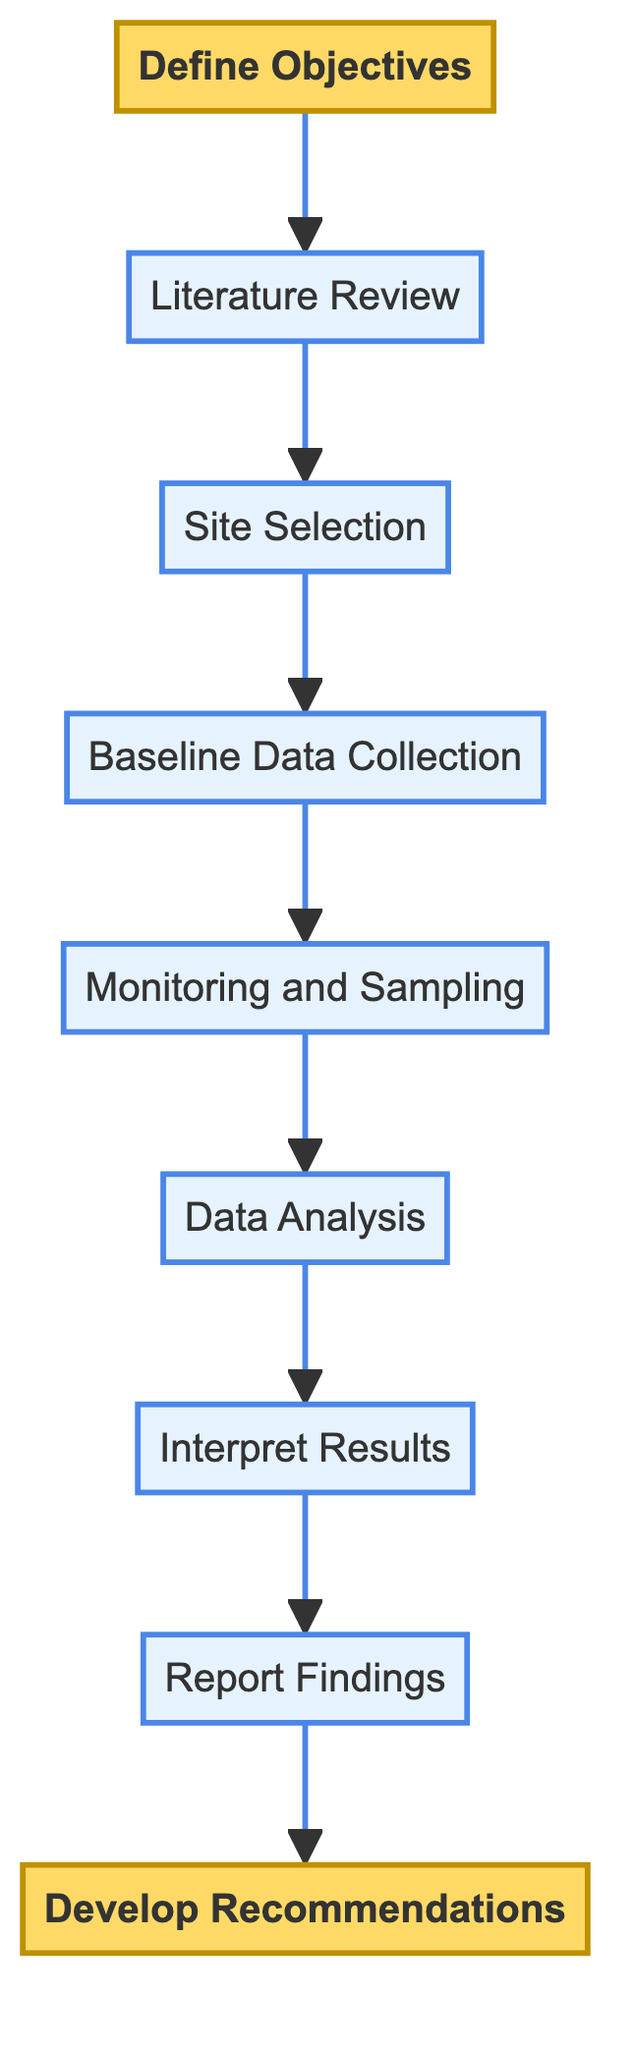What is the final step in the diagram? The diagram shows a flow from bottom to top, with the last step at the top being "Develop Recommendations," which is the final outcome of the study process.
Answer: Develop Recommendations How many steps are in the flowchart? The diagram contains a total of 9 distinct steps that detail the process for conducting a comparative study.
Answer: 9 What step follows "Data Analysis"? The flow proceeds from "Data Analysis" to "Interpret Results," indicating that after analyzing the data, the next action is to interpret it.
Answer: Interpret Results What step comes before "Baseline Data Collection"? In the diagram, "Baseline Data Collection" is preceded by "Site Selection," meaning that site selection must occur before baseline data can be collected.
Answer: Site Selection What is the main focus of the "Define Objectives" step? "Define Objectives" is centered around establishing specific goals for the study, such as understanding species diversity and population density.
Answer: Comparing species diversity and population density Which step involves gathering initial data? The step labeled "Baseline Data Collection" is where initial data from both MPA and non-MPA sites is collected, including various important metrics.
Answer: Baseline Data Collection How does "Monitoring and Sampling" relate to "Data Analysis"? After "Monitoring and Sampling" is completed, the collected data is analyzed in the next step, which is "Data Analysis," thus indicating a sequential relationship between them.
Answer: Monitoring and Sampling leads to Data Analysis What step is directly after "Report Findings"? Following the "Report Findings" step, the next action is "Develop Recommendations," indicating that once findings are shared, recommendations are formulated based on those findings.
Answer: Develop Recommendations What type of review is conducted before site selection? A "Literature Review" is conducted prior to choosing sites, allowing the researcher to gather existing knowledge that informs site selection.
Answer: Literature Review 